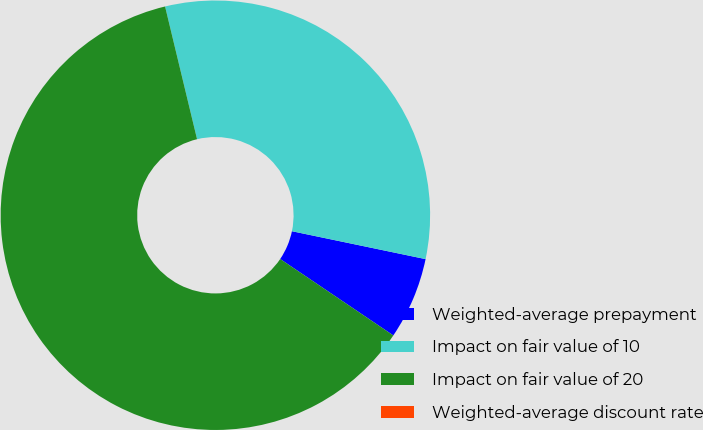Convert chart to OTSL. <chart><loc_0><loc_0><loc_500><loc_500><pie_chart><fcel>Weighted-average prepayment<fcel>Impact on fair value of 10<fcel>Impact on fair value of 20<fcel>Weighted-average discount rate<nl><fcel>6.18%<fcel>32.04%<fcel>61.78%<fcel>0.0%<nl></chart> 